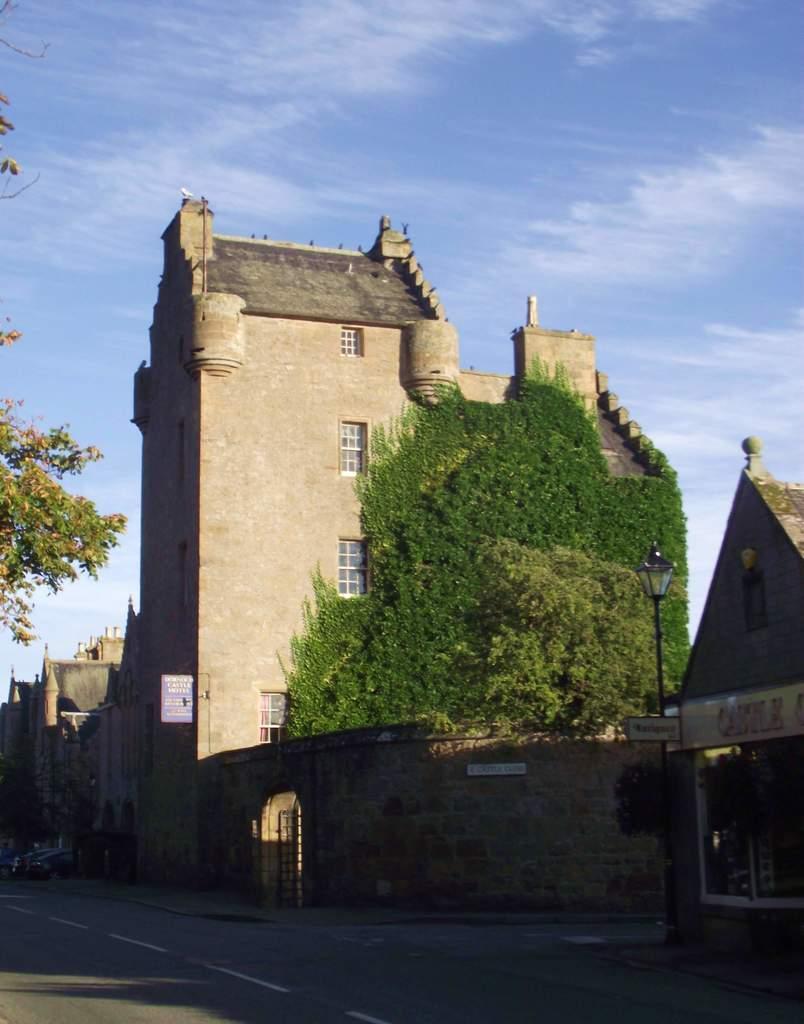Describe this image in one or two sentences. In this image, we can see house, buildings, walls, windows, trees, boards, poles and vehicles. At the bottom, there is a road. Background we can see the sky. 